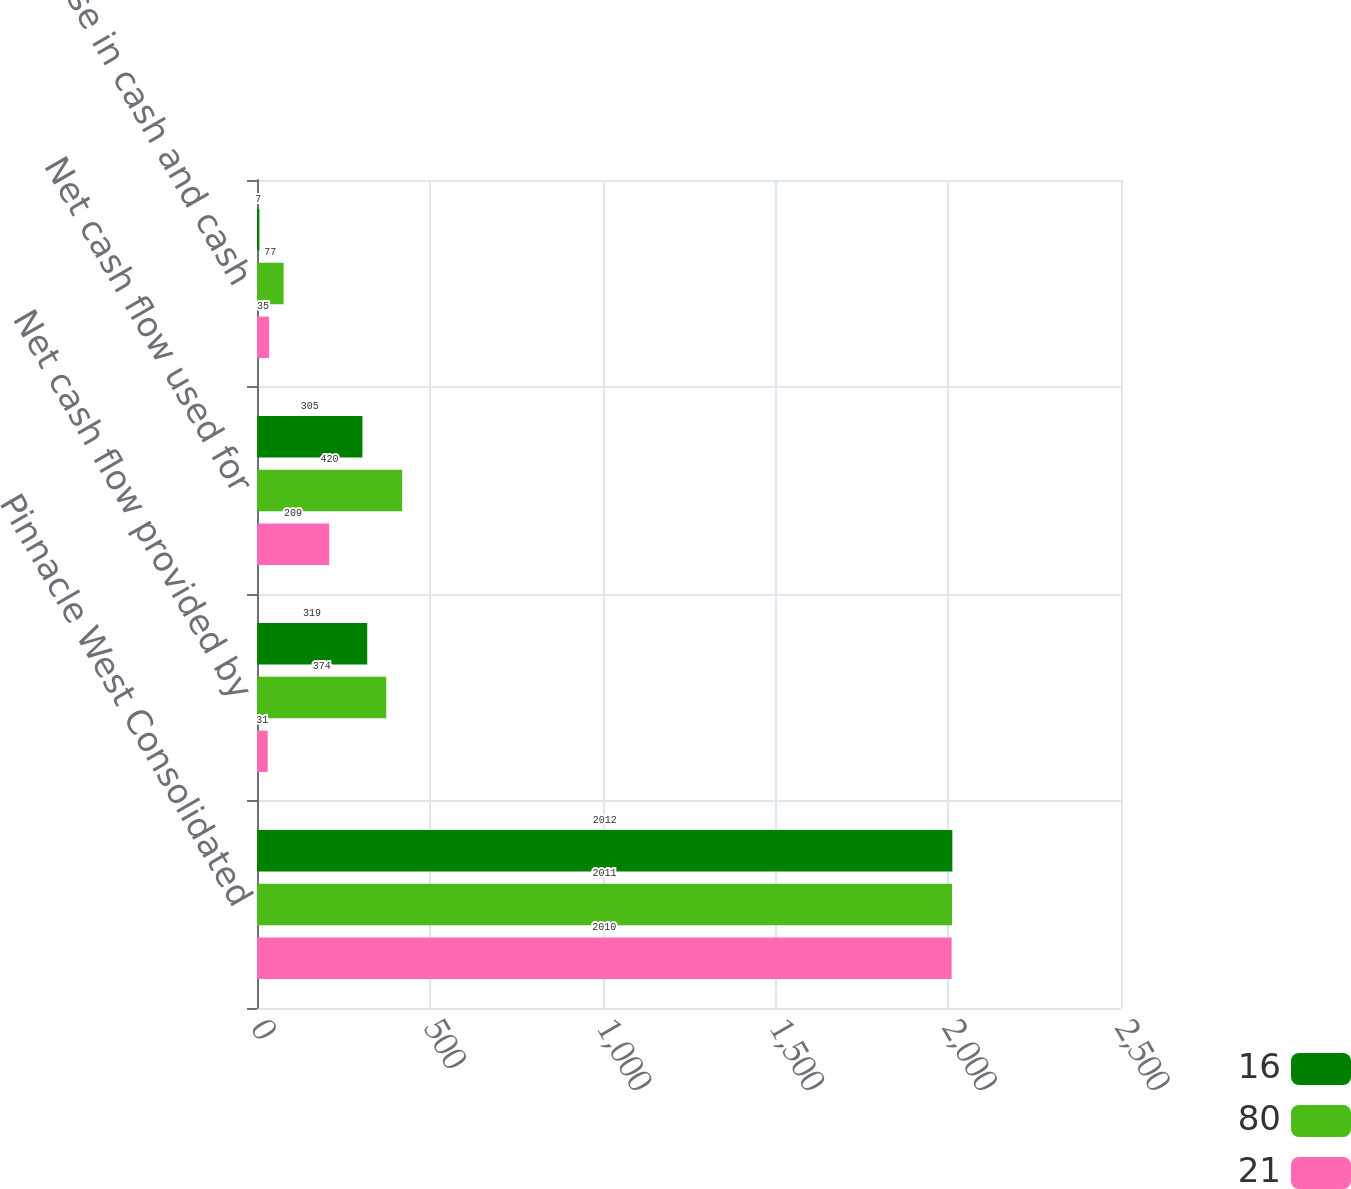Convert chart to OTSL. <chart><loc_0><loc_0><loc_500><loc_500><stacked_bar_chart><ecel><fcel>Pinnacle West Consolidated<fcel>Net cash flow provided by<fcel>Net cash flow used for<fcel>Net decrease in cash and cash<nl><fcel>16<fcel>2012<fcel>319<fcel>305<fcel>7<nl><fcel>80<fcel>2011<fcel>374<fcel>420<fcel>77<nl><fcel>21<fcel>2010<fcel>31<fcel>209<fcel>35<nl></chart> 